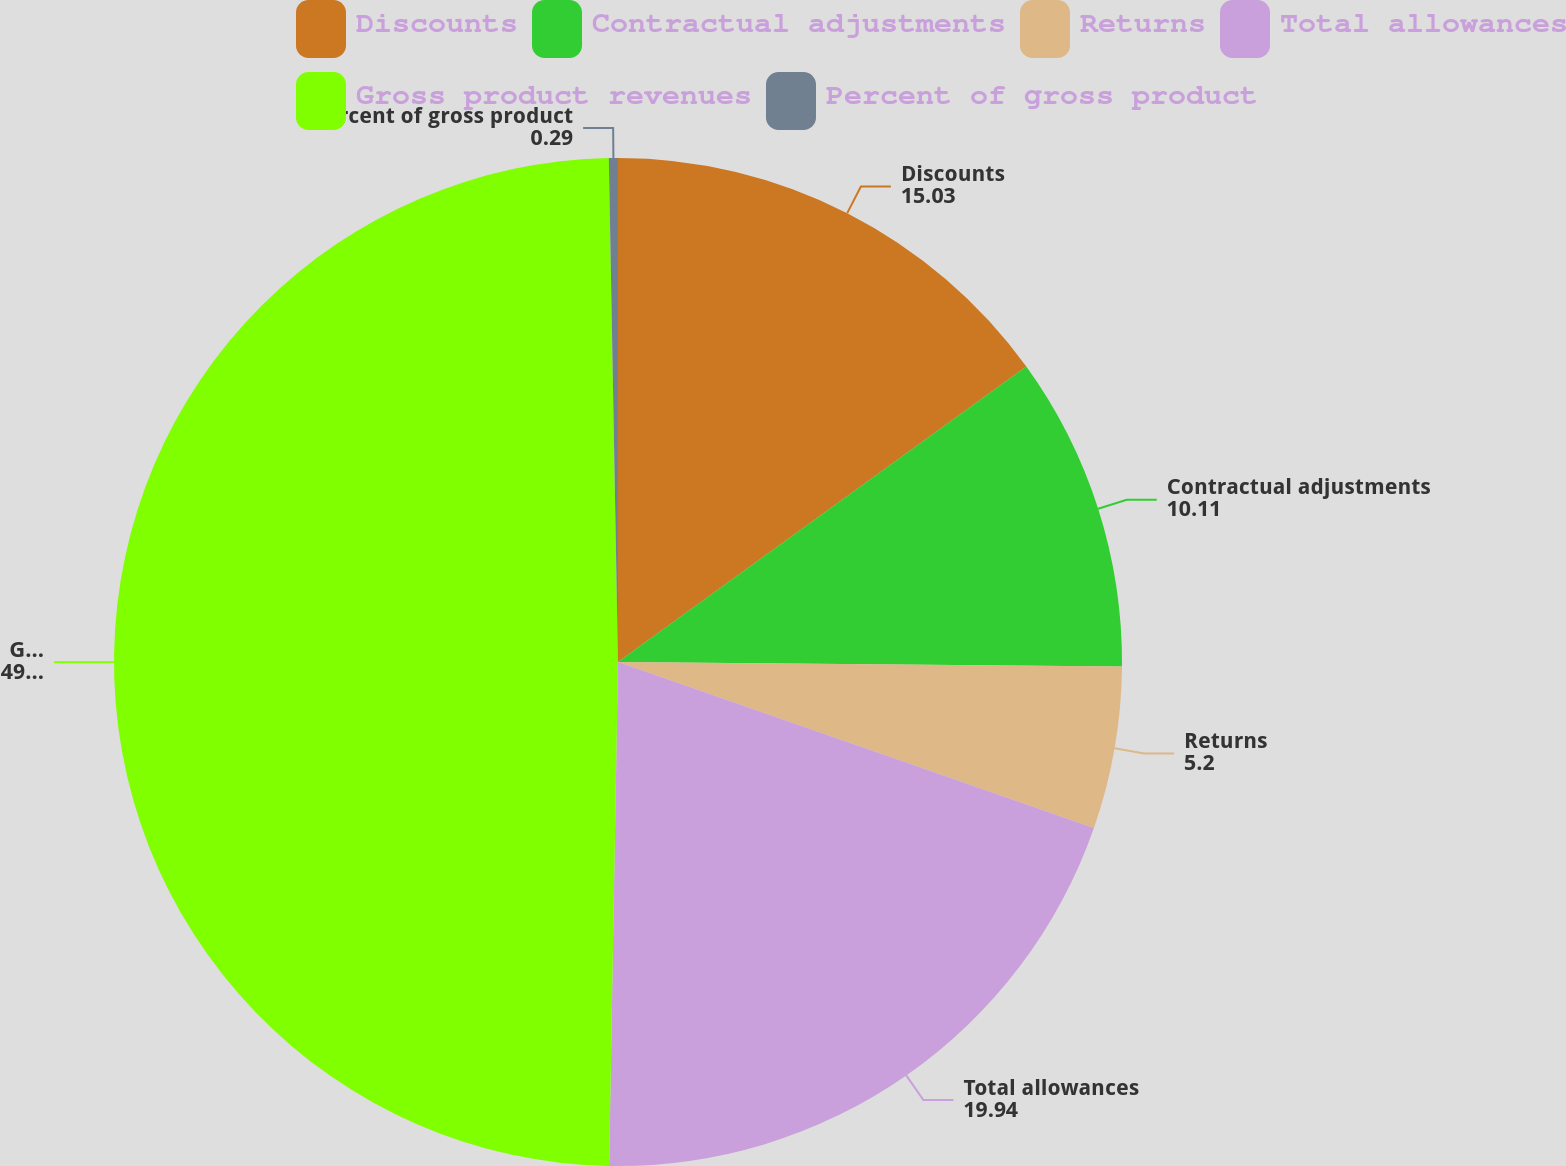<chart> <loc_0><loc_0><loc_500><loc_500><pie_chart><fcel>Discounts<fcel>Contractual adjustments<fcel>Returns<fcel>Total allowances<fcel>Gross product revenues<fcel>Percent of gross product<nl><fcel>15.03%<fcel>10.11%<fcel>5.2%<fcel>19.94%<fcel>49.43%<fcel>0.29%<nl></chart> 